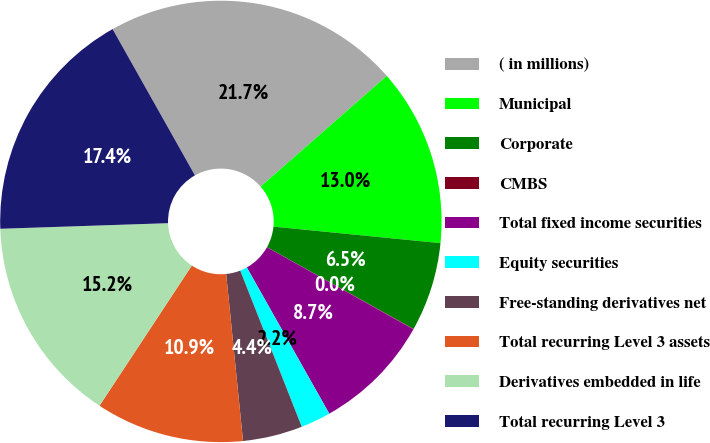Convert chart. <chart><loc_0><loc_0><loc_500><loc_500><pie_chart><fcel>( in millions)<fcel>Municipal<fcel>Corporate<fcel>CMBS<fcel>Total fixed income securities<fcel>Equity securities<fcel>Free-standing derivatives net<fcel>Total recurring Level 3 assets<fcel>Derivatives embedded in life<fcel>Total recurring Level 3<nl><fcel>21.7%<fcel>13.03%<fcel>6.53%<fcel>0.03%<fcel>8.7%<fcel>2.2%<fcel>4.37%<fcel>10.87%<fcel>15.2%<fcel>17.37%<nl></chart> 